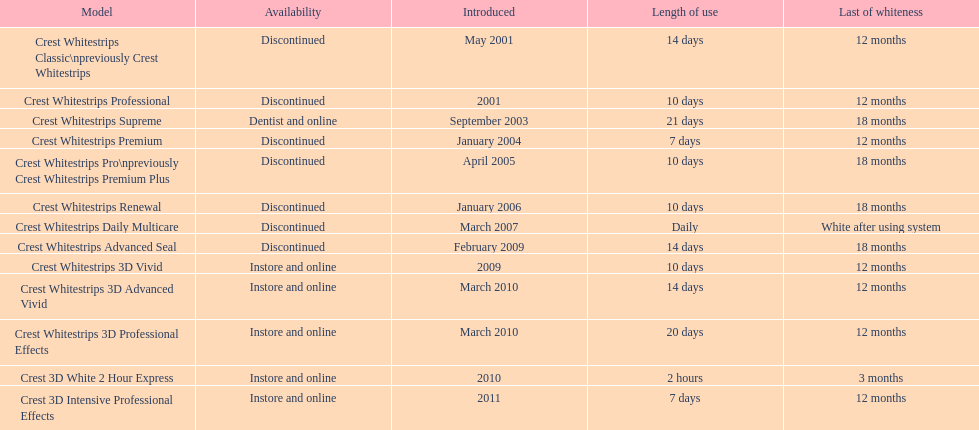Does the crest white strips pro last as long as the crest white strips renewal? Yes. Could you parse the entire table? {'header': ['Model', 'Availability', 'Introduced', 'Length of use', 'Last of whiteness'], 'rows': [['Crest Whitestrips Classic\\npreviously Crest Whitestrips', 'Discontinued', 'May 2001', '14 days', '12 months'], ['Crest Whitestrips Professional', 'Discontinued', '2001', '10 days', '12 months'], ['Crest Whitestrips Supreme', 'Dentist and online', 'September 2003', '21 days', '18 months'], ['Crest Whitestrips Premium', 'Discontinued', 'January 2004', '7 days', '12 months'], ['Crest Whitestrips Pro\\npreviously Crest Whitestrips Premium Plus', 'Discontinued', 'April 2005', '10 days', '18 months'], ['Crest Whitestrips Renewal', 'Discontinued', 'January 2006', '10 days', '18 months'], ['Crest Whitestrips Daily Multicare', 'Discontinued', 'March 2007', 'Daily', 'White after using system'], ['Crest Whitestrips Advanced Seal', 'Discontinued', 'February 2009', '14 days', '18 months'], ['Crest Whitestrips 3D Vivid', 'Instore and online', '2009', '10 days', '12 months'], ['Crest Whitestrips 3D Advanced Vivid', 'Instore and online', 'March 2010', '14 days', '12 months'], ['Crest Whitestrips 3D Professional Effects', 'Instore and online', 'March 2010', '20 days', '12 months'], ['Crest 3D White 2 Hour Express', 'Instore and online', '2010', '2 hours', '3 months'], ['Crest 3D Intensive Professional Effects', 'Instore and online', '2011', '7 days', '12 months']]} 